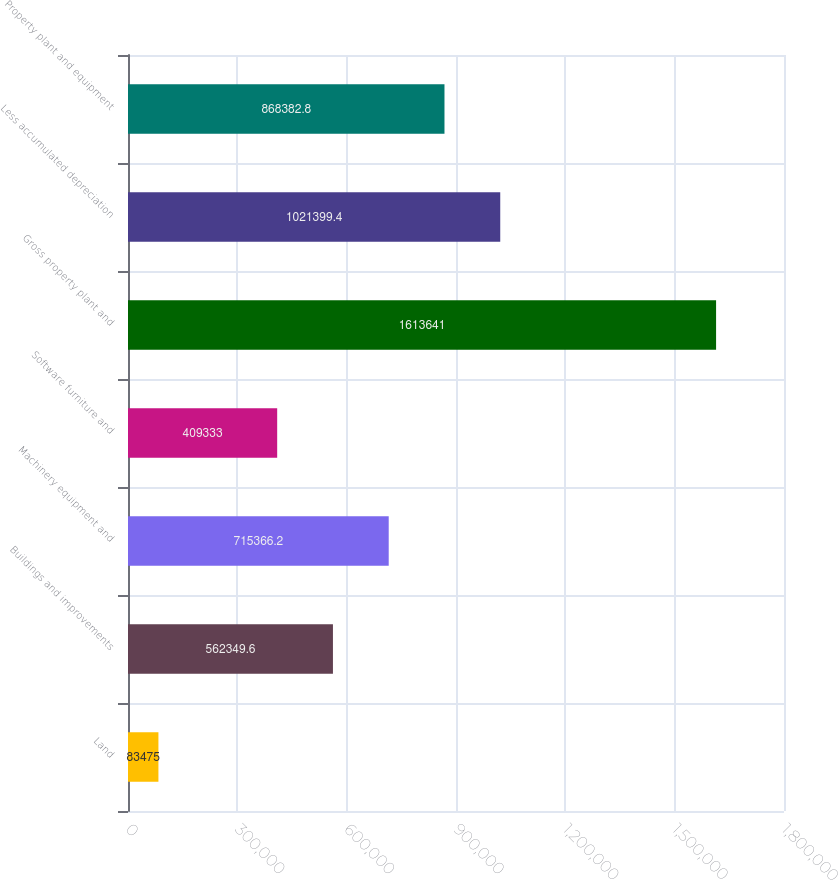Convert chart to OTSL. <chart><loc_0><loc_0><loc_500><loc_500><bar_chart><fcel>Land<fcel>Buildings and improvements<fcel>Machinery equipment and<fcel>Software furniture and<fcel>Gross property plant and<fcel>Less accumulated depreciation<fcel>Property plant and equipment<nl><fcel>83475<fcel>562350<fcel>715366<fcel>409333<fcel>1.61364e+06<fcel>1.0214e+06<fcel>868383<nl></chart> 